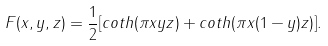<formula> <loc_0><loc_0><loc_500><loc_500>F ( x , y , z ) = \frac { 1 } { 2 } [ c o t h ( \pi x y z ) + c o t h ( \pi x ( 1 - y ) z ) ] .</formula> 